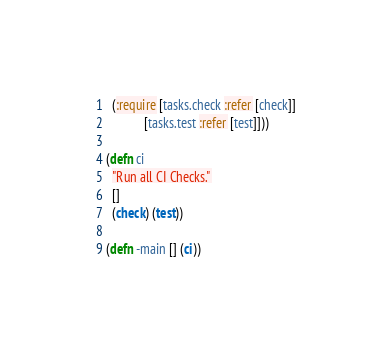Convert code to text. <code><loc_0><loc_0><loc_500><loc_500><_Clojure_>  (:require [tasks.check :refer [check]]
            [tasks.test :refer [test]]))

(defn ci
  "Run all CI Checks."
  []
  (check) (test))

(defn -main [] (ci))
</code> 